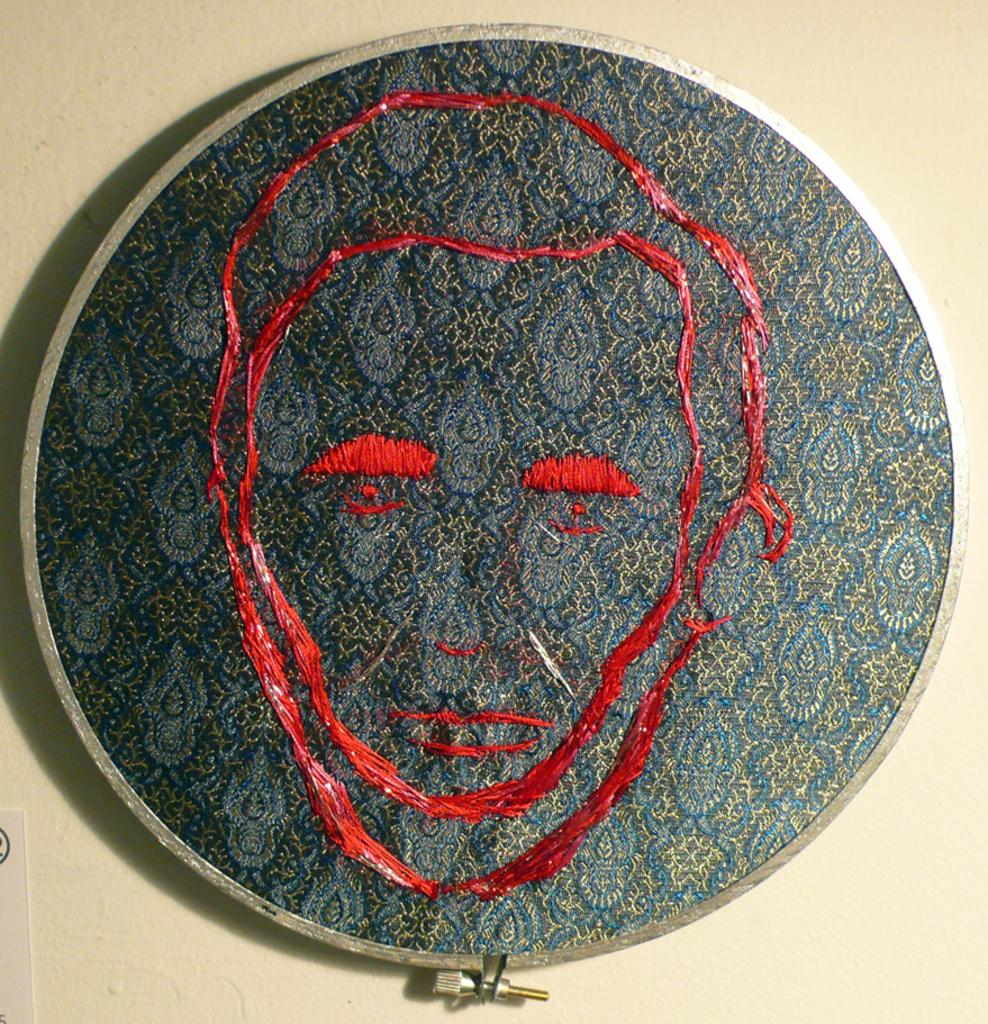What is the primary color of the surface in the image? The primary color of the surface in the image is cream. What is placed on the surface? There is a cloth on the surface. What type of decoration can be seen on the cloth? The cloth has embroidery made with a red-colored thread. What type of bag is visible in the image? There is no bag present in the image. How many clams can be seen on the cloth? There are no clams present in the image; the cloth has embroidery made with a red-colored thread. 